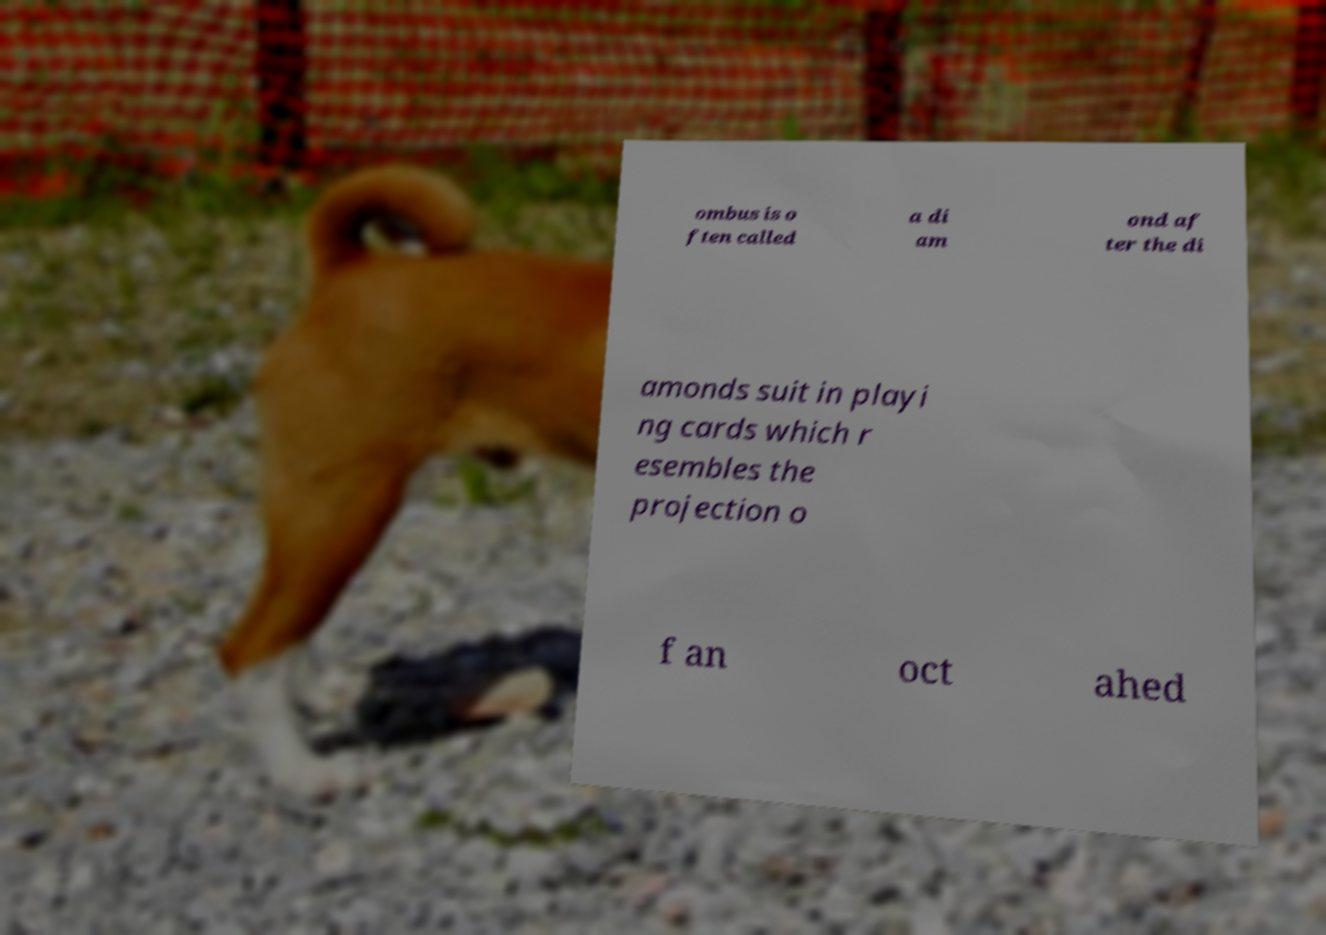Please identify and transcribe the text found in this image. ombus is o ften called a di am ond af ter the di amonds suit in playi ng cards which r esembles the projection o f an oct ahed 